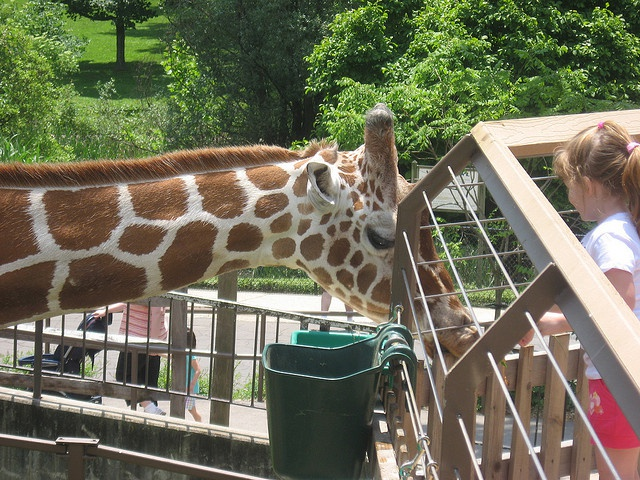Describe the objects in this image and their specific colors. I can see giraffe in olive, maroon, gray, and darkgray tones, people in olive, gray, white, and brown tones, people in olive, black, darkgray, gray, and lightpink tones, and people in olive, darkgray, tan, gray, and teal tones in this image. 